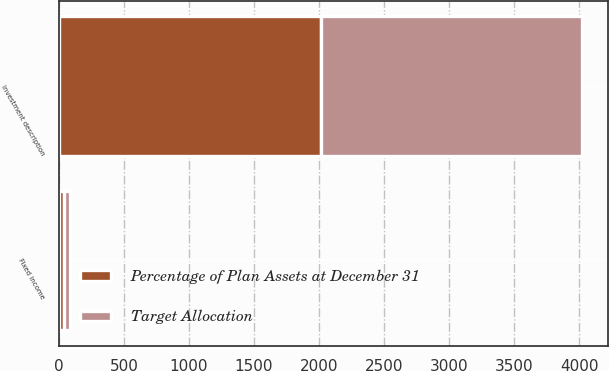<chart> <loc_0><loc_0><loc_500><loc_500><stacked_bar_chart><ecel><fcel>Investment description<fcel>Fixed income<nl><fcel>Percentage of Plan Assets at December 31<fcel>2012<fcel>40<nl><fcel>Target Allocation<fcel>2011<fcel>42.2<nl></chart> 